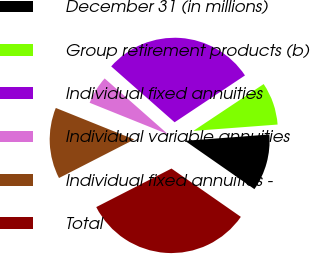Convert chart. <chart><loc_0><loc_0><loc_500><loc_500><pie_chart><fcel>December 31 (in millions)<fcel>Group retirement products (b)<fcel>Individual fixed annuities<fcel>Individual variable annuities<fcel>Individual fixed annuities -<fcel>Total<nl><fcel>10.88%<fcel>8.15%<fcel>29.15%<fcel>5.41%<fcel>13.62%<fcel>32.78%<nl></chart> 